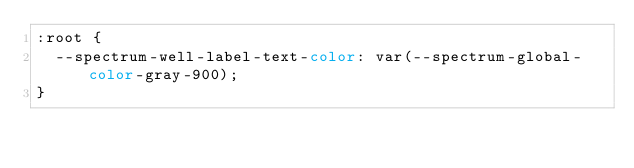Convert code to text. <code><loc_0><loc_0><loc_500><loc_500><_CSS_>:root {
  --spectrum-well-label-text-color: var(--spectrum-global-color-gray-900);
}
</code> 